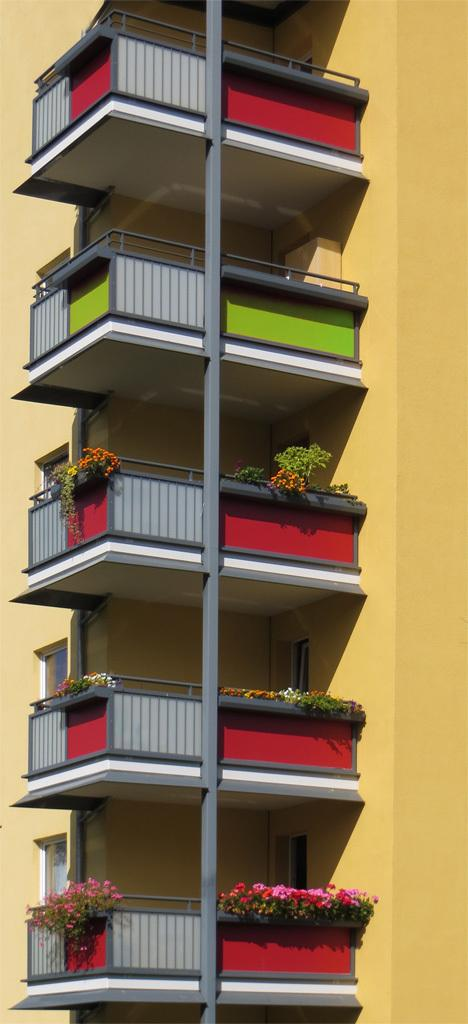What type of structure is present in the image? There is a building in the image. What type of natural elements can be seen in the image? There are flowers visible in the image. What type of rod can be seen holding up the flowers in the image? There is no rod visible in the image; the flowers are not being held up by any visible support. What type of jeans is the building wearing in the image? Buildings do not wear jeans, as they are inanimate structures. 